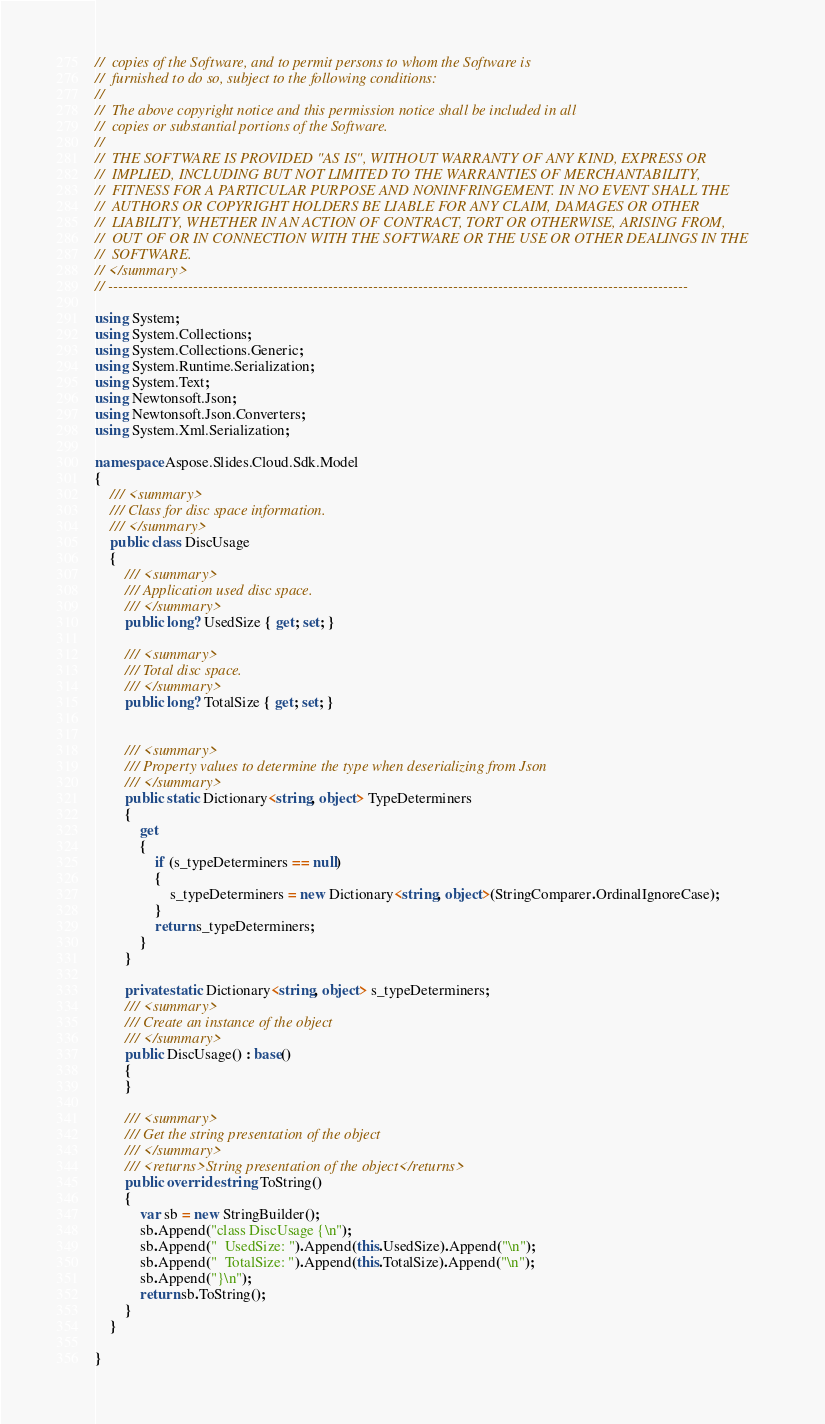<code> <loc_0><loc_0><loc_500><loc_500><_C#_>//  copies of the Software, and to permit persons to whom the Software is
//  furnished to do so, subject to the following conditions:
// 
//  The above copyright notice and this permission notice shall be included in all
//  copies or substantial portions of the Software.
// 
//  THE SOFTWARE IS PROVIDED "AS IS", WITHOUT WARRANTY OF ANY KIND, EXPRESS OR
//  IMPLIED, INCLUDING BUT NOT LIMITED TO THE WARRANTIES OF MERCHANTABILITY,
//  FITNESS FOR A PARTICULAR PURPOSE AND NONINFRINGEMENT. IN NO EVENT SHALL THE
//  AUTHORS OR COPYRIGHT HOLDERS BE LIABLE FOR ANY CLAIM, DAMAGES OR OTHER
//  LIABILITY, WHETHER IN AN ACTION OF CONTRACT, TORT OR OTHERWISE, ARISING FROM,
//  OUT OF OR IN CONNECTION WITH THE SOFTWARE OR THE USE OR OTHER DEALINGS IN THE
//  SOFTWARE.
// </summary>
// --------------------------------------------------------------------------------------------------------------------

using System;
using System.Collections;
using System.Collections.Generic;
using System.Runtime.Serialization;
using System.Text;
using Newtonsoft.Json;
using Newtonsoft.Json.Converters;
using System.Xml.Serialization;

namespace Aspose.Slides.Cloud.Sdk.Model
{
    /// <summary>
    /// Class for disc space information.
    /// </summary>  
    public class DiscUsage 
    {                       
        /// <summary>
        /// Application used disc space.
        /// </summary>
        public long? UsedSize { get; set; }

        /// <summary>
        /// Total disc space.
        /// </summary>
        public long? TotalSize { get; set; }


        /// <summary>
        /// Property values to determine the type when deserializing from Json
        /// </summary>
        public static Dictionary<string, object> TypeDeterminers
        {
            get
            {
                if (s_typeDeterminers == null)
                {
                    s_typeDeterminers = new Dictionary<string, object>(StringComparer.OrdinalIgnoreCase);
                }
                return s_typeDeterminers;
            }
        }

        private static Dictionary<string, object> s_typeDeterminers;
        /// <summary>
        /// Create an instance of the object
        /// </summary>
        public DiscUsage() : base()
        {
        }

        /// <summary>
        /// Get the string presentation of the object
        /// </summary>
        /// <returns>String presentation of the object</returns>
        public override string ToString()  
        {
            var sb = new StringBuilder();
            sb.Append("class DiscUsage {\n");
            sb.Append("  UsedSize: ").Append(this.UsedSize).Append("\n");
            sb.Append("  TotalSize: ").Append(this.TotalSize).Append("\n");
            sb.Append("}\n");
            return sb.ToString();
        }
    }

}
</code> 